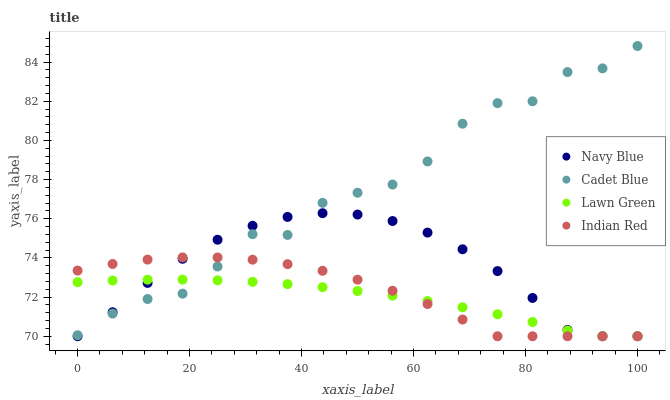Does Lawn Green have the minimum area under the curve?
Answer yes or no. Yes. Does Cadet Blue have the maximum area under the curve?
Answer yes or no. Yes. Does Indian Red have the minimum area under the curve?
Answer yes or no. No. Does Indian Red have the maximum area under the curve?
Answer yes or no. No. Is Lawn Green the smoothest?
Answer yes or no. Yes. Is Cadet Blue the roughest?
Answer yes or no. Yes. Is Indian Red the smoothest?
Answer yes or no. No. Is Indian Red the roughest?
Answer yes or no. No. Does Navy Blue have the lowest value?
Answer yes or no. Yes. Does Cadet Blue have the lowest value?
Answer yes or no. No. Does Cadet Blue have the highest value?
Answer yes or no. Yes. Does Indian Red have the highest value?
Answer yes or no. No. Does Cadet Blue intersect Indian Red?
Answer yes or no. Yes. Is Cadet Blue less than Indian Red?
Answer yes or no. No. Is Cadet Blue greater than Indian Red?
Answer yes or no. No. 